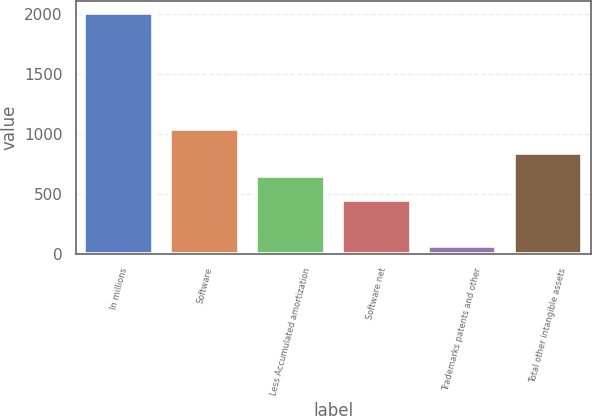<chart> <loc_0><loc_0><loc_500><loc_500><bar_chart><fcel>In millions<fcel>Software<fcel>Less Accumulated amortization<fcel>Software net<fcel>Trademarks patents and other<fcel>Total other intangible assets<nl><fcel>2015<fcel>1038<fcel>647.2<fcel>451.8<fcel>61<fcel>842.6<nl></chart> 